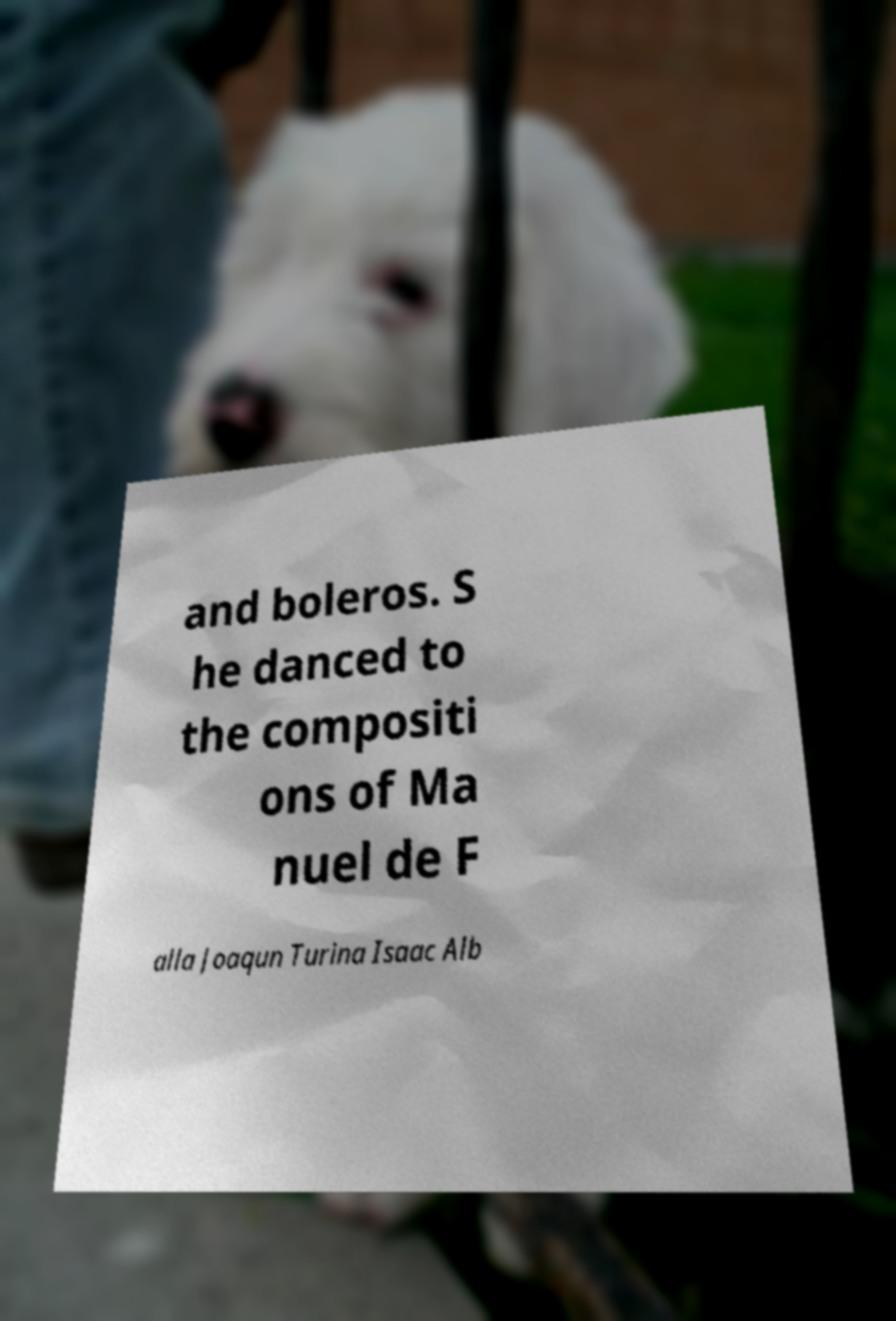Can you accurately transcribe the text from the provided image for me? and boleros. S he danced to the compositi ons of Ma nuel de F alla Joaqun Turina Isaac Alb 